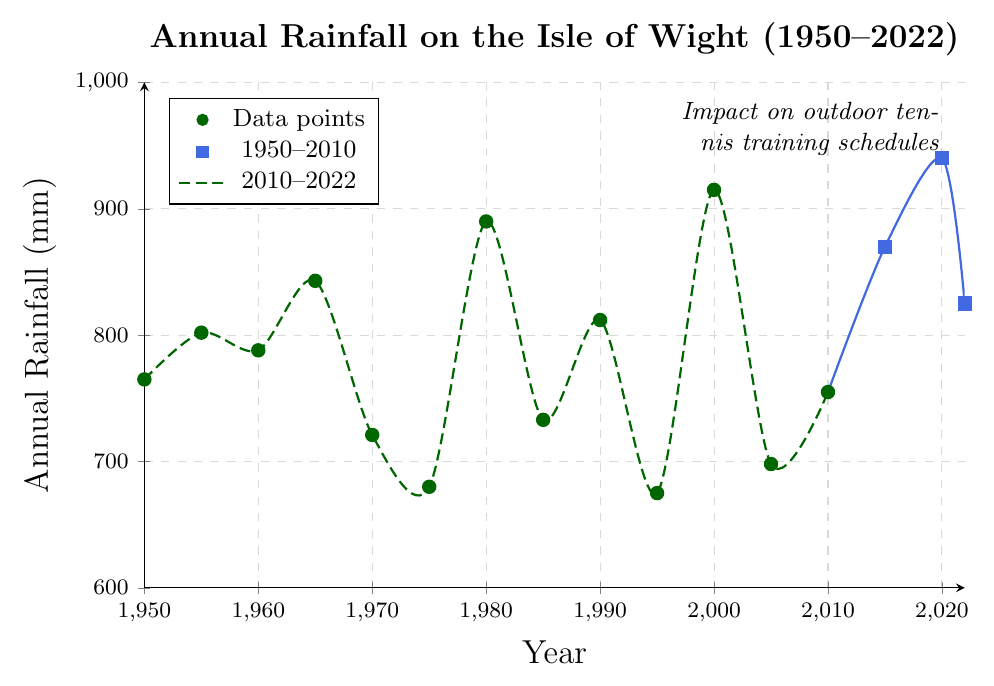Which year had the highest annual rainfall from 2015 to 2022? Look at the data points and observe which point has the highest vertical position from 2015 to 2022. The highest point is in the year 2020 with 940 mm.
Answer: 2020 By how much did the annual rainfall change between 2000 and 2005? Subtract the annual rainfall in 2005 from that in 2000. The difference is 915 mm - 698 mm = 217 mm.
Answer: 217 mm What is the average annual rainfall for the years 1950, 1960, and 1970? Add the annual rainfall values for 1950, 1960, and 1970, then divide by the number of years: (765 + 788 + 721) / 3 = 724.67 mm.
Answer: 724.67 mm Which period showed more variability in annual rainfall: 1950-2010 or 2010-2022? Compare the range and fluctuations in the data points for both periods. The period 2010-2022 shows larger fluctuations, ranging from 755 mm to 940 mm, whereas 1950-2010 has variations but seems less extreme overall.
Answer: 2010-2022 What trend do you observe in the annual rainfall from 2010 to 2022? Examine the line plot from 2010 to 2022. It shows an increasing trend up to 2020, followed by a slight decrease in 2022.
Answer: Increasing then decreasing Compare the annual rainfall in 1980 with that in 2000. Which year had higher rainfall? Look at the heights of the data points in 1980 and 2000. The point in 2000 is higher, with 915 mm compared to 890 mm in 1980.
Answer: 2000 What is the visual color and shape difference between data points for the periods 1950-2010 and 2015-2022? Examine the data points' color and shape. Data points from 1950-2010 are marked with green circles, while those from 2015-2022 are marked with blue squares.
Answer: Green circles and blue squares Calculate the total annual rainfall for the years from 1990 to 2000. Add the values for each year from 1990 to 2000: 812 + 675 + 915 = 2402 mm.
Answer: 2402 mm In which year did the annual rainfall fall below 700 mm? Identify the year on the horizontal axis and observe the corresponding vertical position below the 700 mm mark. This occurred in 1995 with 675 mm.
Answer: 1995 What can you infer about the impact of changing rainfall patterns on outdoor tennis training schedules from 2010 to 2022? Higher variability and increased rainfall, especially in 2020 (940 mm), imply more potential disruptions in outdoor tennis training schedules. Detailed reasoning: 2010-2022 shows increased fluctuations and higher peak rainfall, leading to more unpredictable conditions for scheduling outdoor activities.
Answer: More disruptions due to higher variability and increased rainfall 